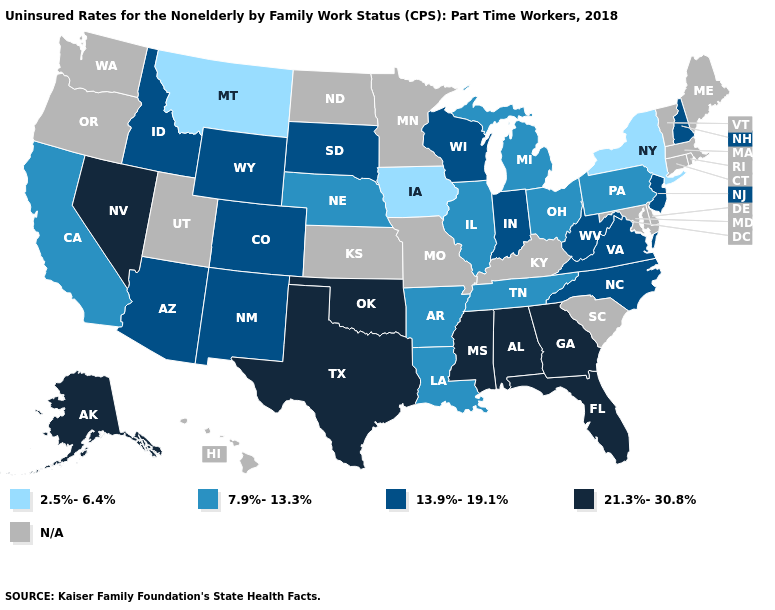Name the states that have a value in the range 13.9%-19.1%?
Be succinct. Arizona, Colorado, Idaho, Indiana, New Hampshire, New Jersey, New Mexico, North Carolina, South Dakota, Virginia, West Virginia, Wisconsin, Wyoming. Does the first symbol in the legend represent the smallest category?
Concise answer only. Yes. What is the lowest value in the USA?
Short answer required. 2.5%-6.4%. What is the lowest value in the USA?
Quick response, please. 2.5%-6.4%. Which states have the lowest value in the MidWest?
Quick response, please. Iowa. Among the states that border Nebraska , which have the highest value?
Keep it brief. Colorado, South Dakota, Wyoming. What is the value of West Virginia?
Be succinct. 13.9%-19.1%. How many symbols are there in the legend?
Be succinct. 5. Among the states that border Tennessee , which have the highest value?
Give a very brief answer. Alabama, Georgia, Mississippi. Is the legend a continuous bar?
Concise answer only. No. Which states have the highest value in the USA?
Be succinct. Alabama, Alaska, Florida, Georgia, Mississippi, Nevada, Oklahoma, Texas. Name the states that have a value in the range N/A?
Answer briefly. Connecticut, Delaware, Hawaii, Kansas, Kentucky, Maine, Maryland, Massachusetts, Minnesota, Missouri, North Dakota, Oregon, Rhode Island, South Carolina, Utah, Vermont, Washington. Among the states that border Kansas , does Colorado have the lowest value?
Give a very brief answer. No. 